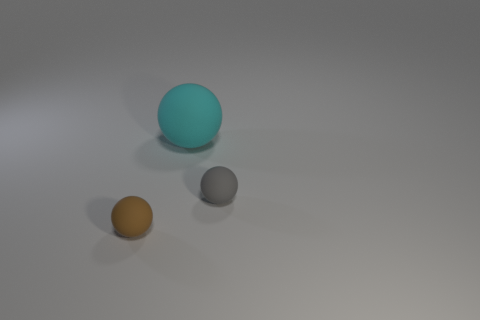Subtract all brown matte balls. How many balls are left? 2 Add 2 big red spheres. How many objects exist? 5 Subtract all cyan spheres. How many spheres are left? 2 Add 1 spheres. How many spheres exist? 4 Subtract 1 gray balls. How many objects are left? 2 Subtract all red balls. Subtract all gray cylinders. How many balls are left? 3 Subtract all brown cylinders. How many green spheres are left? 0 Subtract all small matte objects. Subtract all yellow matte cubes. How many objects are left? 1 Add 3 brown balls. How many brown balls are left? 4 